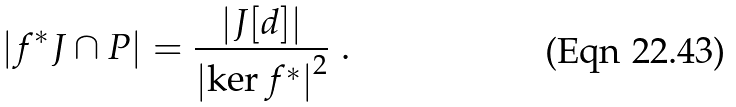Convert formula to latex. <formula><loc_0><loc_0><loc_500><loc_500>\left | f ^ { * } J \cap P \right | = \frac { \left | J [ d ] \right | } { \left | \ker f ^ { * } \right | ^ { 2 } } \ .</formula> 